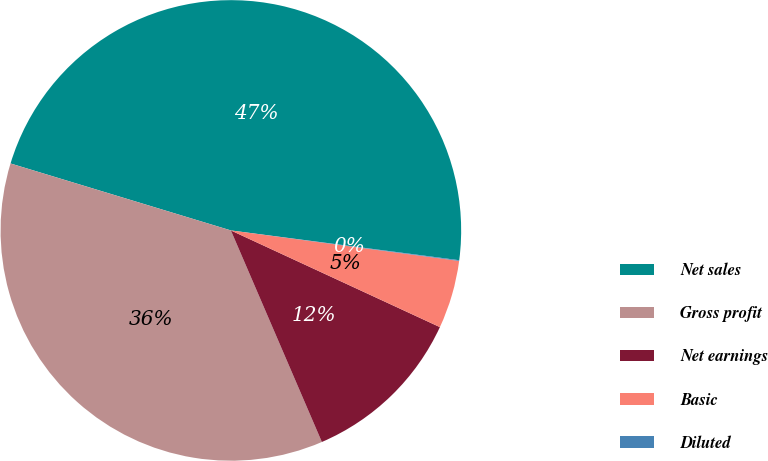Convert chart to OTSL. <chart><loc_0><loc_0><loc_500><loc_500><pie_chart><fcel>Net sales<fcel>Gross profit<fcel>Net earnings<fcel>Basic<fcel>Diluted<nl><fcel>47.37%<fcel>36.16%<fcel>11.64%<fcel>4.78%<fcel>0.05%<nl></chart> 